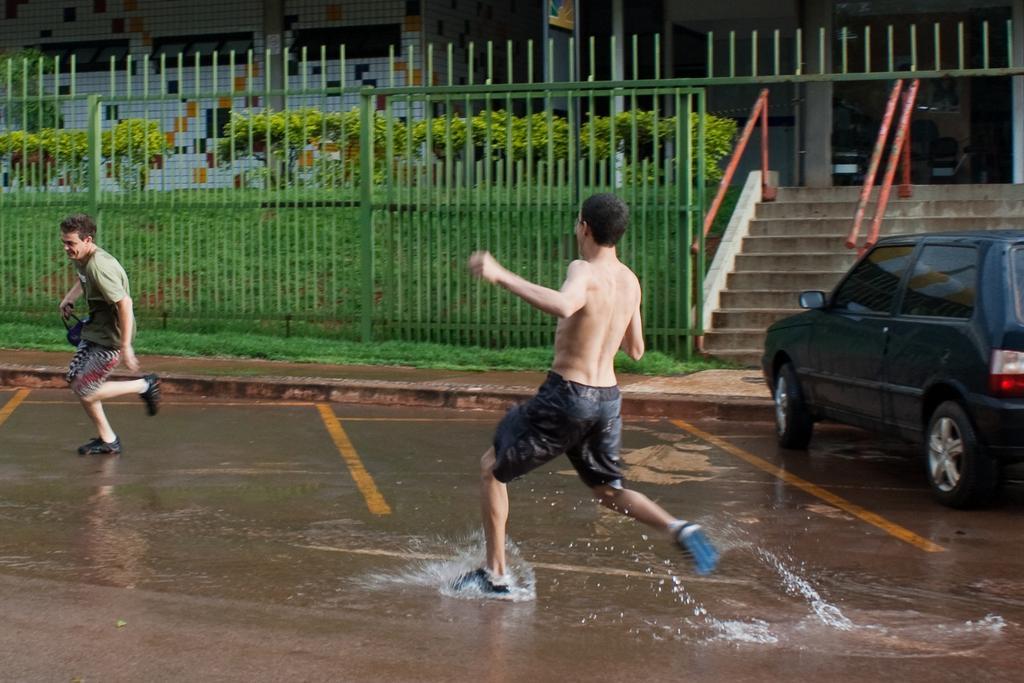In one or two sentences, can you explain what this image depicts? In this image we can see two men are running on the road. In the background, we can see fence, grass, plants, railing, stairs and building. There is a car on the right side of the image. We can see water on the road. 